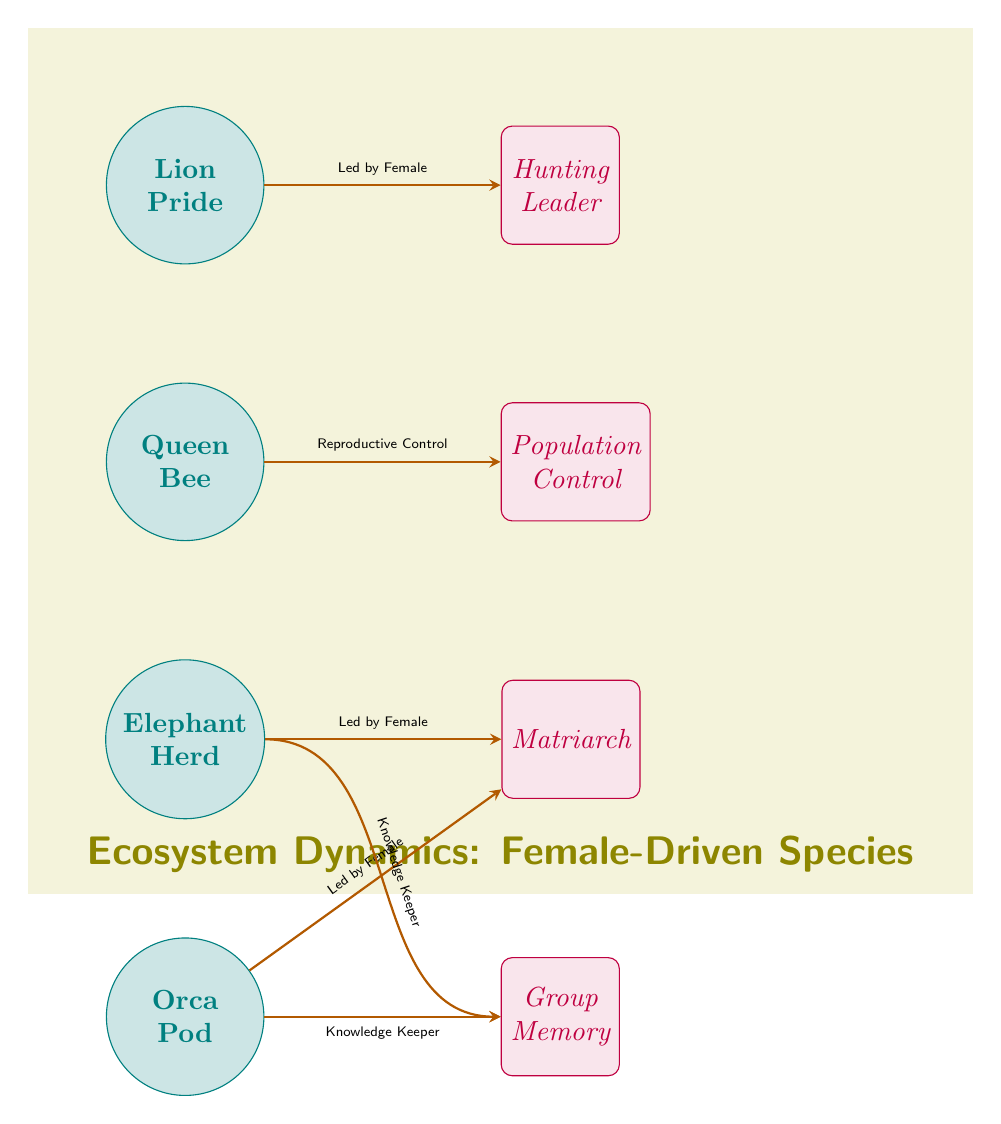What species is identified as a "Herd"? The diagram specifically identifies "Elephant" as a species classified as a "Herd." This can be found by checking the species nodes listed vertically; "Elephant" is one of them along with its description.
Answer: Elephant Which species is responsible for "Population Control"? The "Queen Bee" node is directly connected to the role labeled "Population Control." This is determined by verifying that the arrows lead from the species node to its corresponding role node, which indicates the responsibility.
Answer: Queen Bee What role does the "Matriarch" indicate? The "Matriarch" appears as a role associated with both the "Elephant Herd" and the "Orca Pod." Further examination of the connections shows both species are connected to the matriarch role via arrows labeled "Led by Female."
Answer: Matriarch How many species are depicted in the diagram? The diagram includes four species nodes: Lion, Queen Bee, Elephant, and Orca. Tallying these nodes, we find the total by counting each distinct circle labeled as a species.
Answer: Four How many connections are there leading from species to roles? There are four arrows indicating connections from species to roles, each representing the specific influence or driving role that the female species holds in their respective ecosystem. This is done by counting the directed arrows in the diagram.
Answer: Four What knowledge-related role do both the Elephant and Orca share? Both the elephants and orcas are connected to the role indicating they serve as "Knowledge Keepers," shown by the arrows coming from the respective species nodes toward the "Group Memory" role. This is confirmed by examining the directed connections from each species to this role node.
Answer: Knowledge Keeper Which species is noted as "Led by Female"? Both the "Lion Pride" and "Orca Pod" are noted as "Led by Female" through the connections that explicitly describe their leadership structures within the arrows leading to the "Hunting Leader" and "Matriarch" roles respectively. This can be derived from the labels on the connecting arrows.
Answer: Lion, Orca In what habitat or category do these species dynamics fit? The overarching theme of this diagram suggests it portrays species dynamics specifically within the context of ecosystems where female leadership plays a significant role, as indicated by the title at the top. This conclusion comes from synthesizing the entire visualization and the linked themes.
Answer: Ecosystem Dynamics 